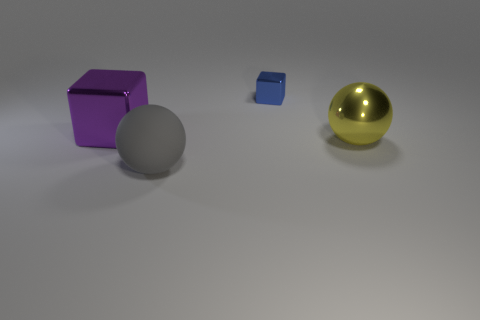Subtract all gray spheres. How many spheres are left? 1 Subtract all red spheres. Subtract all green cubes. How many spheres are left? 2 Subtract all blue spheres. How many gray blocks are left? 0 Subtract all purple metal objects. Subtract all purple metal balls. How many objects are left? 3 Add 2 big spheres. How many big spheres are left? 4 Add 1 large purple things. How many large purple things exist? 2 Add 3 yellow rubber cylinders. How many objects exist? 7 Subtract 0 red balls. How many objects are left? 4 